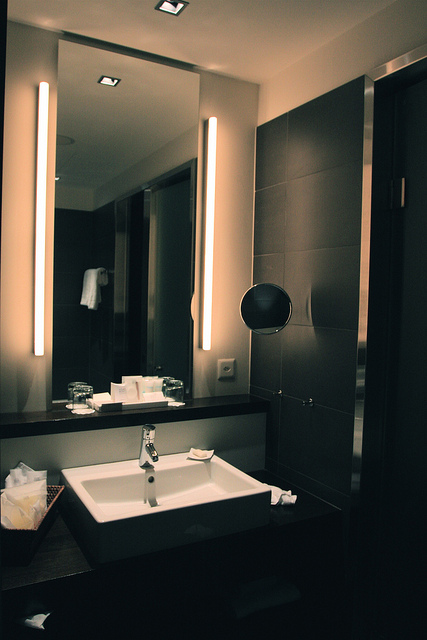Imagine you are in this bathroom. What sounds and scents might you experience? In this serene bathroom, you might hear the faint hum of the ventilation system and the gentle trickle of water if the sink were in use. The scent could be a blend of fresh, clean aromas from the soap and possibly a hint of a pleasant air freshener. The overall atmosphere would likely be calm and refreshing, providing a brief escape from the hustle and bustle of daily life. 